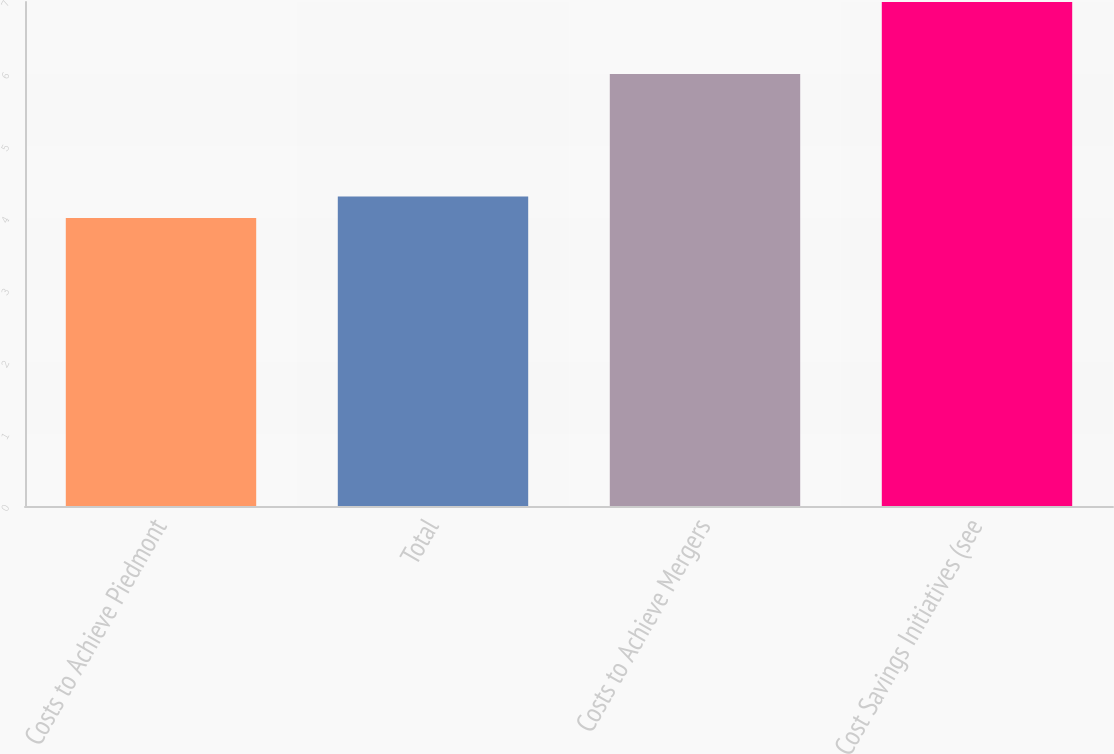<chart> <loc_0><loc_0><loc_500><loc_500><bar_chart><fcel>Costs to Achieve Piedmont<fcel>Total<fcel>Costs to Achieve Mergers<fcel>Cost Savings Initiatives (see<nl><fcel>4<fcel>4.3<fcel>6<fcel>7<nl></chart> 